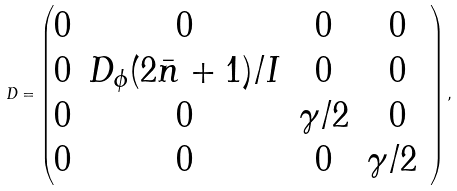Convert formula to latex. <formula><loc_0><loc_0><loc_500><loc_500>D = \begin{pmatrix} 0 & 0 & 0 & 0 \\ 0 & D _ { \phi } ( 2 \bar { n } + 1 ) / I & 0 & 0 \\ 0 & 0 & \gamma / 2 & 0 \\ 0 & 0 & 0 & \gamma / 2 \ \end{pmatrix} ,</formula> 